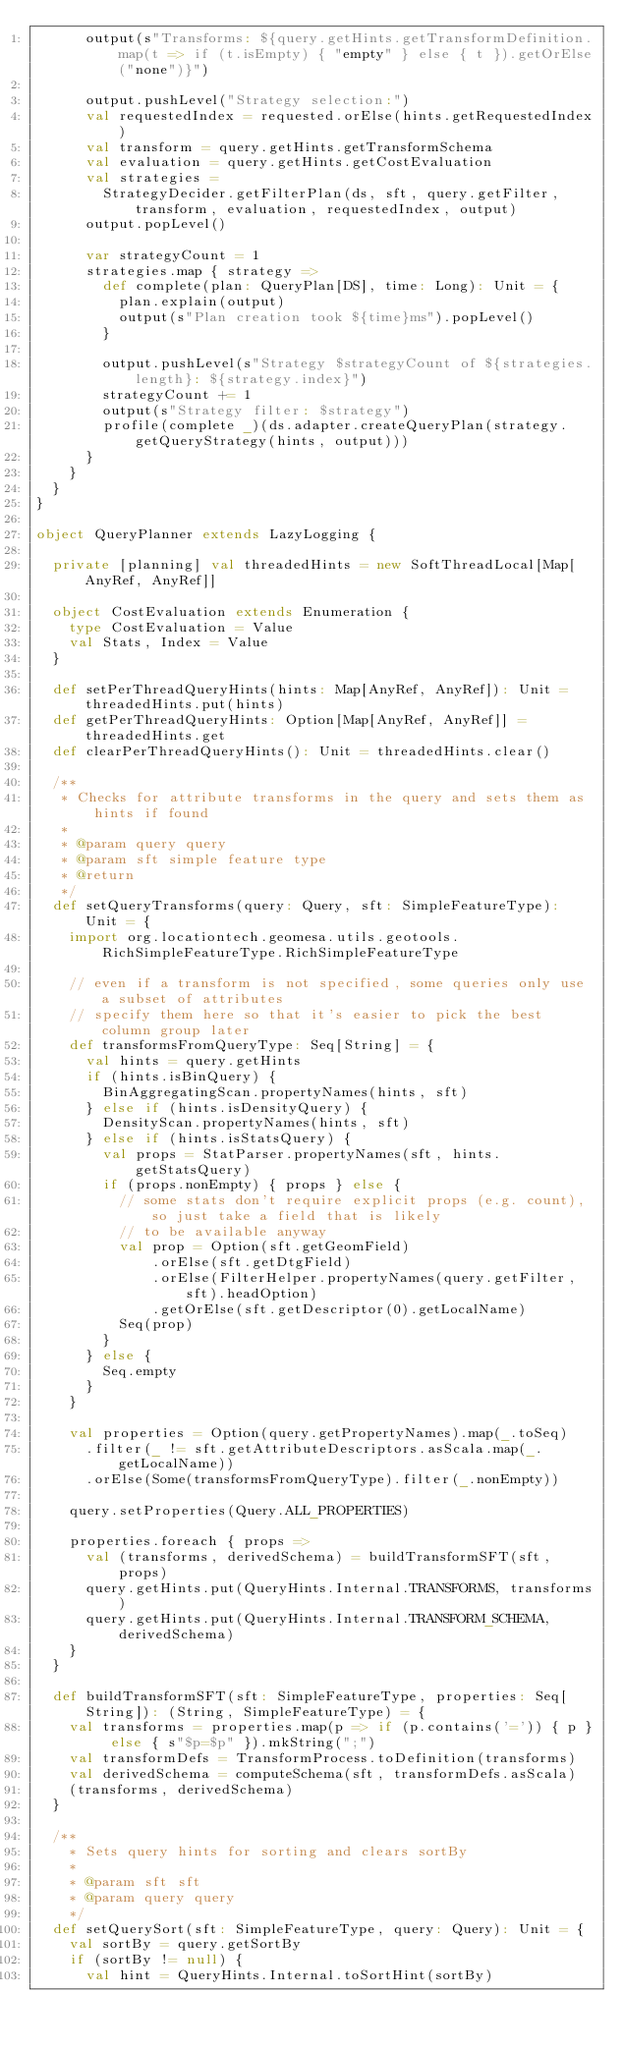Convert code to text. <code><loc_0><loc_0><loc_500><loc_500><_Scala_>      output(s"Transforms: ${query.getHints.getTransformDefinition.map(t => if (t.isEmpty) { "empty" } else { t }).getOrElse("none")}")

      output.pushLevel("Strategy selection:")
      val requestedIndex = requested.orElse(hints.getRequestedIndex)
      val transform = query.getHints.getTransformSchema
      val evaluation = query.getHints.getCostEvaluation
      val strategies =
        StrategyDecider.getFilterPlan(ds, sft, query.getFilter, transform, evaluation, requestedIndex, output)
      output.popLevel()

      var strategyCount = 1
      strategies.map { strategy =>
        def complete(plan: QueryPlan[DS], time: Long): Unit = {
          plan.explain(output)
          output(s"Plan creation took ${time}ms").popLevel()
        }

        output.pushLevel(s"Strategy $strategyCount of ${strategies.length}: ${strategy.index}")
        strategyCount += 1
        output(s"Strategy filter: $strategy")
        profile(complete _)(ds.adapter.createQueryPlan(strategy.getQueryStrategy(hints, output)))
      }
    }
  }
}

object QueryPlanner extends LazyLogging {

  private [planning] val threadedHints = new SoftThreadLocal[Map[AnyRef, AnyRef]]

  object CostEvaluation extends Enumeration {
    type CostEvaluation = Value
    val Stats, Index = Value
  }

  def setPerThreadQueryHints(hints: Map[AnyRef, AnyRef]): Unit = threadedHints.put(hints)
  def getPerThreadQueryHints: Option[Map[AnyRef, AnyRef]] = threadedHints.get
  def clearPerThreadQueryHints(): Unit = threadedHints.clear()

  /**
   * Checks for attribute transforms in the query and sets them as hints if found
   *
   * @param query query
   * @param sft simple feature type
   * @return
   */
  def setQueryTransforms(query: Query, sft: SimpleFeatureType): Unit = {
    import org.locationtech.geomesa.utils.geotools.RichSimpleFeatureType.RichSimpleFeatureType

    // even if a transform is not specified, some queries only use a subset of attributes
    // specify them here so that it's easier to pick the best column group later
    def transformsFromQueryType: Seq[String] = {
      val hints = query.getHints
      if (hints.isBinQuery) {
        BinAggregatingScan.propertyNames(hints, sft)
      } else if (hints.isDensityQuery) {
        DensityScan.propertyNames(hints, sft)
      } else if (hints.isStatsQuery) {
        val props = StatParser.propertyNames(sft, hints.getStatsQuery)
        if (props.nonEmpty) { props } else {
          // some stats don't require explicit props (e.g. count), so just take a field that is likely
          // to be available anyway
          val prop = Option(sft.getGeomField)
              .orElse(sft.getDtgField)
              .orElse(FilterHelper.propertyNames(query.getFilter, sft).headOption)
              .getOrElse(sft.getDescriptor(0).getLocalName)
          Seq(prop)
        }
      } else {
        Seq.empty
      }
    }

    val properties = Option(query.getPropertyNames).map(_.toSeq)
      .filter(_ != sft.getAttributeDescriptors.asScala.map(_.getLocalName))
      .orElse(Some(transformsFromQueryType).filter(_.nonEmpty))

    query.setProperties(Query.ALL_PROPERTIES)

    properties.foreach { props =>
      val (transforms, derivedSchema) = buildTransformSFT(sft, props)
      query.getHints.put(QueryHints.Internal.TRANSFORMS, transforms)
      query.getHints.put(QueryHints.Internal.TRANSFORM_SCHEMA, derivedSchema)
    }
  }

  def buildTransformSFT(sft: SimpleFeatureType, properties: Seq[String]): (String, SimpleFeatureType) = {
    val transforms = properties.map(p => if (p.contains('=')) { p } else { s"$p=$p" }).mkString(";")
    val transformDefs = TransformProcess.toDefinition(transforms)
    val derivedSchema = computeSchema(sft, transformDefs.asScala)
    (transforms, derivedSchema)
  }

  /**
    * Sets query hints for sorting and clears sortBy
    *
    * @param sft sft
    * @param query query
    */
  def setQuerySort(sft: SimpleFeatureType, query: Query): Unit = {
    val sortBy = query.getSortBy
    if (sortBy != null) {
      val hint = QueryHints.Internal.toSortHint(sortBy)</code> 